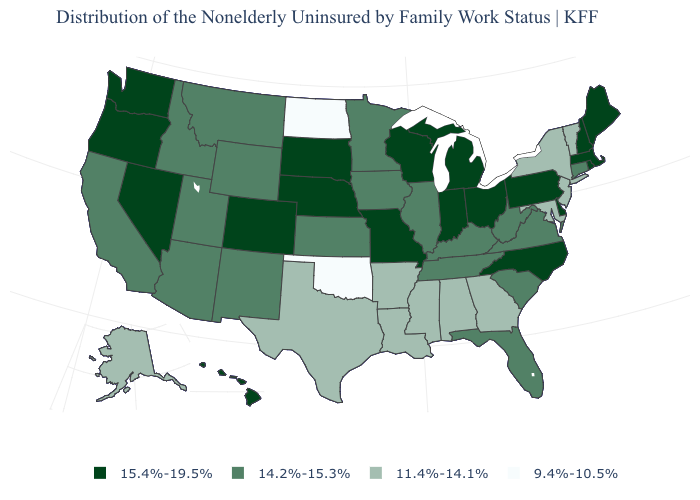Does the map have missing data?
Answer briefly. No. What is the value of Kentucky?
Answer briefly. 14.2%-15.3%. Does New Hampshire have a higher value than North Dakota?
Concise answer only. Yes. Among the states that border Washington , which have the highest value?
Quick response, please. Oregon. Name the states that have a value in the range 15.4%-19.5%?
Give a very brief answer. Colorado, Delaware, Hawaii, Indiana, Maine, Massachusetts, Michigan, Missouri, Nebraska, Nevada, New Hampshire, North Carolina, Ohio, Oregon, Pennsylvania, Rhode Island, South Dakota, Washington, Wisconsin. What is the value of Maine?
Be succinct. 15.4%-19.5%. Does New York have the highest value in the Northeast?
Concise answer only. No. Does Kentucky have the highest value in the USA?
Keep it brief. No. What is the highest value in the Northeast ?
Be succinct. 15.4%-19.5%. Among the states that border Nebraska , does Missouri have the highest value?
Write a very short answer. Yes. Does Montana have the same value as Texas?
Write a very short answer. No. What is the highest value in states that border South Carolina?
Keep it brief. 15.4%-19.5%. Does Rhode Island have a higher value than Michigan?
Be succinct. No. Does North Dakota have the lowest value in the MidWest?
Be succinct. Yes. What is the highest value in states that border Missouri?
Write a very short answer. 15.4%-19.5%. 